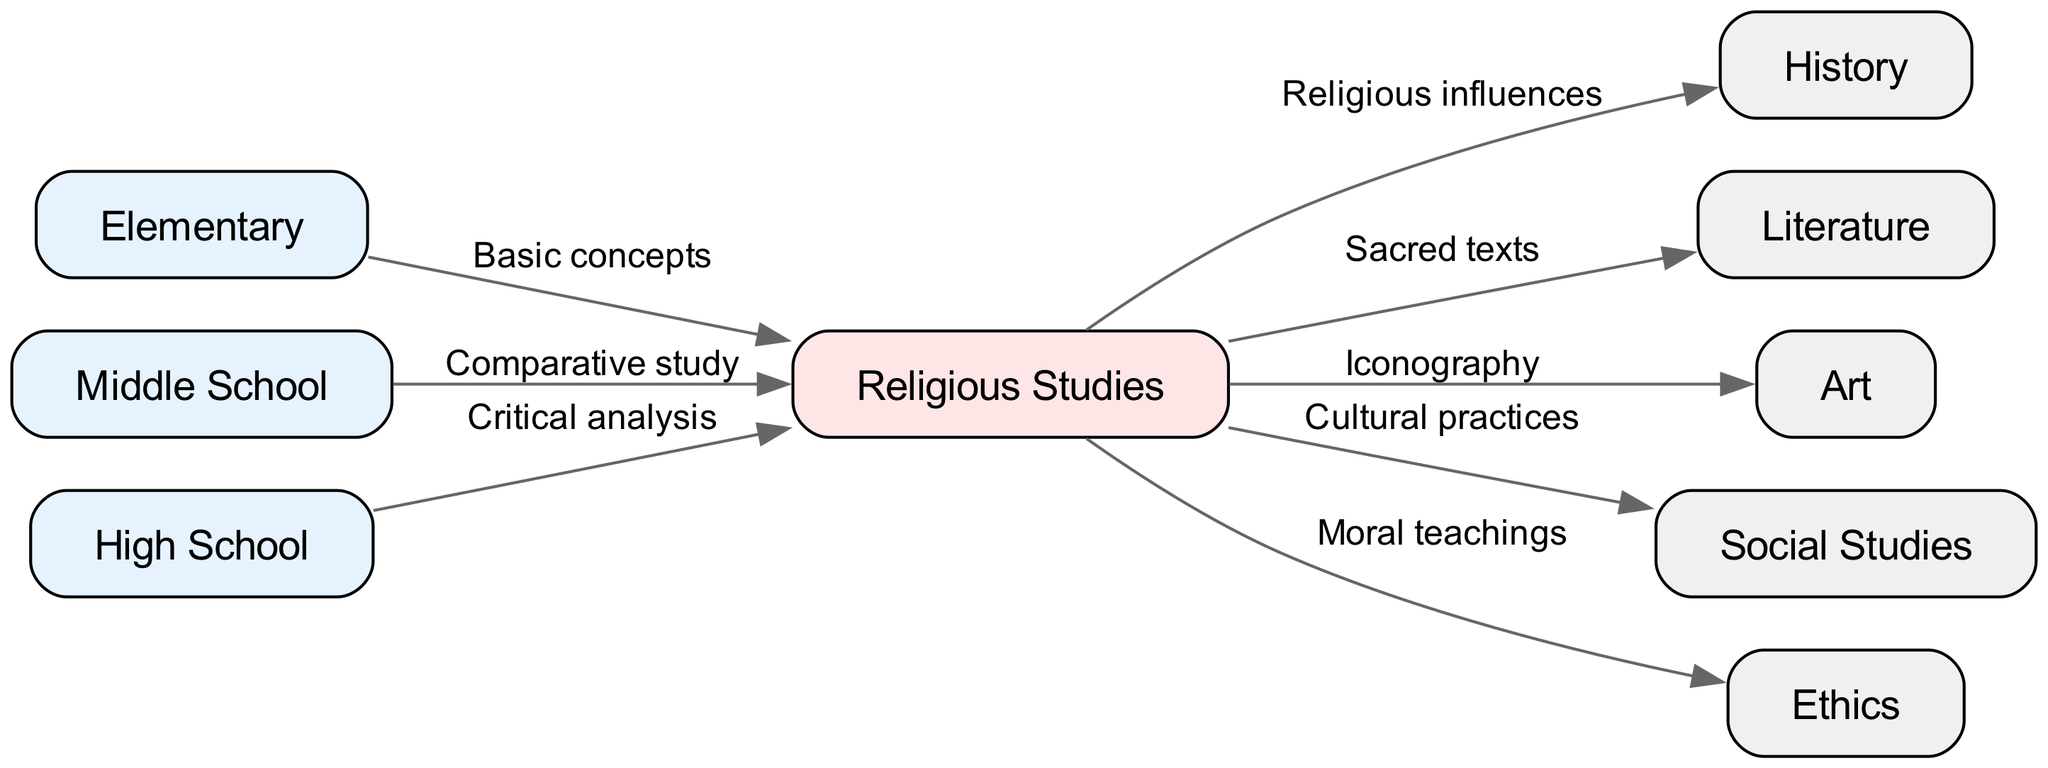What is the central node in the diagram? The central node, where multiple edges originate, is "Religious Studies," which connects to various subjects and grade levels.
Answer: Religious Studies How many nodes are present in the diagram? By counting all the distinct nodes listed, we find there are a total of 9 nodes present in the diagram.
Answer: 9 What subject is directly influenced by "Religious Studies" that includes "Cultural practices"? The subject influenced by "Religious Studies" and related to "Cultural practices" is "Social Studies."
Answer: Social Studies Which grade level studies "Basic concepts"? The grade level that studies "Basic concepts" as indicated in the diagram is "Elementary."
Answer: Elementary Identify the relationship label connecting "Religious Studies" to "Ethics." The relationship label connecting these two nodes is "Moral teachings."
Answer: Moral teachings What type of study is emphasized in "Middle School" regarding "Religious Studies"? The type of study emphasized for "Religious Studies" in "Middle School" is a "Comparative study."
Answer: Comparative study How many edges connect to the "Religious Studies" node? There are 6 distinct edges connected to the "Religious Studies" node, indicating its relation to various subjects and grade levels.
Answer: 6 Which subject's study includes "Sacred texts"? The subject that includes "Sacred texts" as a direct link from "Religious Studies" is "Literature."
Answer: Literature What is the focus of "High School" in relation to "Religious Studies"? In "High School," the focus in relation to "Religious Studies" is on "Critical analysis."
Answer: Critical analysis 